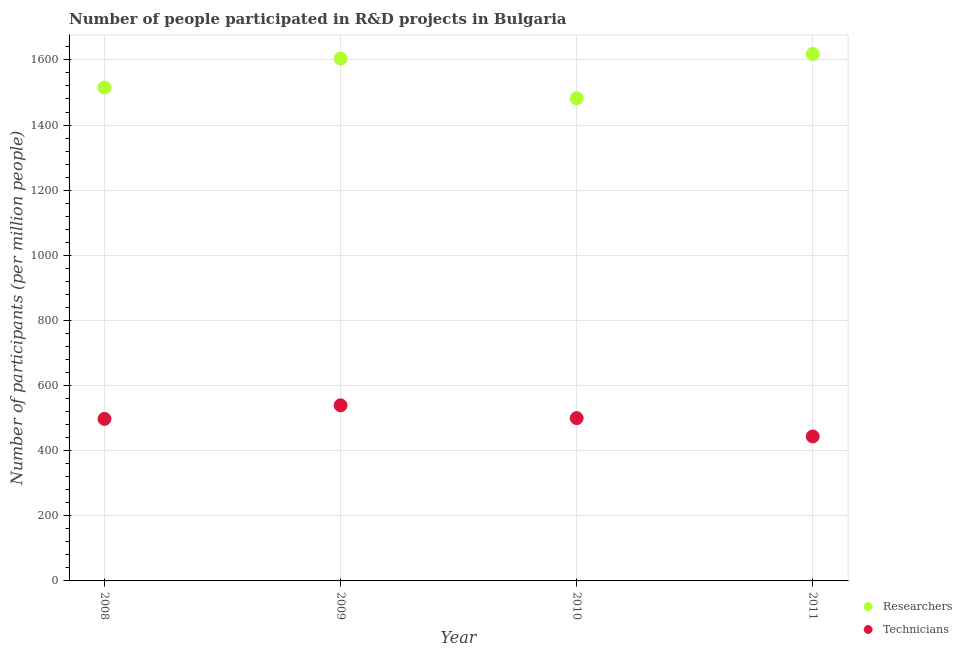How many different coloured dotlines are there?
Make the answer very short. 2. What is the number of technicians in 2009?
Offer a terse response. 539.27. Across all years, what is the maximum number of technicians?
Give a very brief answer. 539.27. Across all years, what is the minimum number of technicians?
Your response must be concise. 443.63. In which year was the number of technicians minimum?
Your response must be concise. 2011. What is the total number of technicians in the graph?
Offer a very short reply. 1980.44. What is the difference between the number of technicians in 2008 and that in 2009?
Provide a short and direct response. -41.78. What is the difference between the number of technicians in 2011 and the number of researchers in 2010?
Offer a very short reply. -1038.56. What is the average number of researchers per year?
Your answer should be very brief. 1554.94. In the year 2009, what is the difference between the number of researchers and number of technicians?
Keep it short and to the point. 1065.01. In how many years, is the number of technicians greater than 1040?
Provide a short and direct response. 0. What is the ratio of the number of researchers in 2010 to that in 2011?
Your answer should be compact. 0.92. Is the difference between the number of researchers in 2010 and 2011 greater than the difference between the number of technicians in 2010 and 2011?
Ensure brevity in your answer.  No. What is the difference between the highest and the second highest number of technicians?
Your response must be concise. 39.22. What is the difference between the highest and the lowest number of technicians?
Your response must be concise. 95.64. Is the sum of the number of technicians in 2009 and 2011 greater than the maximum number of researchers across all years?
Keep it short and to the point. No. Does the number of technicians monotonically increase over the years?
Make the answer very short. No. Is the number of researchers strictly less than the number of technicians over the years?
Ensure brevity in your answer.  No. How many dotlines are there?
Offer a very short reply. 2. What is the difference between two consecutive major ticks on the Y-axis?
Provide a succinct answer. 200. Are the values on the major ticks of Y-axis written in scientific E-notation?
Make the answer very short. No. Does the graph contain grids?
Offer a terse response. Yes. Where does the legend appear in the graph?
Offer a terse response. Bottom right. What is the title of the graph?
Offer a very short reply. Number of people participated in R&D projects in Bulgaria. What is the label or title of the Y-axis?
Your response must be concise. Number of participants (per million people). What is the Number of participants (per million people) in Researchers in 2008?
Your answer should be very brief. 1515.11. What is the Number of participants (per million people) of Technicians in 2008?
Offer a terse response. 497.49. What is the Number of participants (per million people) of Researchers in 2009?
Offer a very short reply. 1604.28. What is the Number of participants (per million people) of Technicians in 2009?
Your answer should be very brief. 539.27. What is the Number of participants (per million people) in Researchers in 2010?
Offer a very short reply. 1482.19. What is the Number of participants (per million people) of Technicians in 2010?
Give a very brief answer. 500.05. What is the Number of participants (per million people) in Researchers in 2011?
Keep it short and to the point. 1618.17. What is the Number of participants (per million people) in Technicians in 2011?
Give a very brief answer. 443.63. Across all years, what is the maximum Number of participants (per million people) in Researchers?
Keep it short and to the point. 1618.17. Across all years, what is the maximum Number of participants (per million people) of Technicians?
Give a very brief answer. 539.27. Across all years, what is the minimum Number of participants (per million people) in Researchers?
Offer a terse response. 1482.19. Across all years, what is the minimum Number of participants (per million people) in Technicians?
Offer a very short reply. 443.63. What is the total Number of participants (per million people) in Researchers in the graph?
Your answer should be very brief. 6219.74. What is the total Number of participants (per million people) of Technicians in the graph?
Offer a terse response. 1980.44. What is the difference between the Number of participants (per million people) in Researchers in 2008 and that in 2009?
Your answer should be very brief. -89.17. What is the difference between the Number of participants (per million people) in Technicians in 2008 and that in 2009?
Provide a succinct answer. -41.78. What is the difference between the Number of participants (per million people) in Researchers in 2008 and that in 2010?
Keep it short and to the point. 32.92. What is the difference between the Number of participants (per million people) in Technicians in 2008 and that in 2010?
Provide a succinct answer. -2.55. What is the difference between the Number of participants (per million people) of Researchers in 2008 and that in 2011?
Keep it short and to the point. -103.06. What is the difference between the Number of participants (per million people) of Technicians in 2008 and that in 2011?
Make the answer very short. 53.87. What is the difference between the Number of participants (per million people) of Researchers in 2009 and that in 2010?
Keep it short and to the point. 122.09. What is the difference between the Number of participants (per million people) in Technicians in 2009 and that in 2010?
Offer a terse response. 39.22. What is the difference between the Number of participants (per million people) of Researchers in 2009 and that in 2011?
Keep it short and to the point. -13.89. What is the difference between the Number of participants (per million people) of Technicians in 2009 and that in 2011?
Your response must be concise. 95.64. What is the difference between the Number of participants (per million people) of Researchers in 2010 and that in 2011?
Your response must be concise. -135.98. What is the difference between the Number of participants (per million people) in Technicians in 2010 and that in 2011?
Provide a succinct answer. 56.42. What is the difference between the Number of participants (per million people) in Researchers in 2008 and the Number of participants (per million people) in Technicians in 2009?
Your response must be concise. 975.84. What is the difference between the Number of participants (per million people) in Researchers in 2008 and the Number of participants (per million people) in Technicians in 2010?
Provide a short and direct response. 1015.06. What is the difference between the Number of participants (per million people) of Researchers in 2008 and the Number of participants (per million people) of Technicians in 2011?
Offer a terse response. 1071.48. What is the difference between the Number of participants (per million people) in Researchers in 2009 and the Number of participants (per million people) in Technicians in 2010?
Provide a short and direct response. 1104.23. What is the difference between the Number of participants (per million people) of Researchers in 2009 and the Number of participants (per million people) of Technicians in 2011?
Provide a short and direct response. 1160.65. What is the difference between the Number of participants (per million people) of Researchers in 2010 and the Number of participants (per million people) of Technicians in 2011?
Your answer should be compact. 1038.56. What is the average Number of participants (per million people) in Researchers per year?
Keep it short and to the point. 1554.94. What is the average Number of participants (per million people) in Technicians per year?
Your response must be concise. 495.11. In the year 2008, what is the difference between the Number of participants (per million people) in Researchers and Number of participants (per million people) in Technicians?
Your answer should be compact. 1017.62. In the year 2009, what is the difference between the Number of participants (per million people) of Researchers and Number of participants (per million people) of Technicians?
Your answer should be very brief. 1065.01. In the year 2010, what is the difference between the Number of participants (per million people) of Researchers and Number of participants (per million people) of Technicians?
Offer a very short reply. 982.14. In the year 2011, what is the difference between the Number of participants (per million people) in Researchers and Number of participants (per million people) in Technicians?
Give a very brief answer. 1174.54. What is the ratio of the Number of participants (per million people) of Researchers in 2008 to that in 2009?
Your answer should be compact. 0.94. What is the ratio of the Number of participants (per million people) of Technicians in 2008 to that in 2009?
Your answer should be compact. 0.92. What is the ratio of the Number of participants (per million people) of Researchers in 2008 to that in 2010?
Provide a succinct answer. 1.02. What is the ratio of the Number of participants (per million people) in Researchers in 2008 to that in 2011?
Make the answer very short. 0.94. What is the ratio of the Number of participants (per million people) in Technicians in 2008 to that in 2011?
Offer a terse response. 1.12. What is the ratio of the Number of participants (per million people) in Researchers in 2009 to that in 2010?
Offer a terse response. 1.08. What is the ratio of the Number of participants (per million people) of Technicians in 2009 to that in 2010?
Ensure brevity in your answer.  1.08. What is the ratio of the Number of participants (per million people) in Technicians in 2009 to that in 2011?
Make the answer very short. 1.22. What is the ratio of the Number of participants (per million people) in Researchers in 2010 to that in 2011?
Give a very brief answer. 0.92. What is the ratio of the Number of participants (per million people) in Technicians in 2010 to that in 2011?
Provide a succinct answer. 1.13. What is the difference between the highest and the second highest Number of participants (per million people) of Researchers?
Provide a succinct answer. 13.89. What is the difference between the highest and the second highest Number of participants (per million people) in Technicians?
Offer a very short reply. 39.22. What is the difference between the highest and the lowest Number of participants (per million people) of Researchers?
Provide a succinct answer. 135.98. What is the difference between the highest and the lowest Number of participants (per million people) of Technicians?
Offer a terse response. 95.64. 